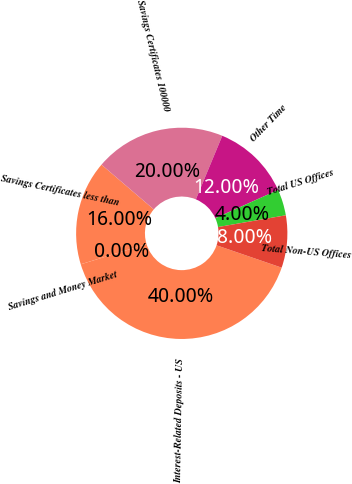<chart> <loc_0><loc_0><loc_500><loc_500><pie_chart><fcel>Interest-Related Deposits - US<fcel>Savings and Money Market<fcel>Savings Certificates less than<fcel>Savings Certificates 100000<fcel>Other Time<fcel>Total US Offices<fcel>Total Non-US Offices<nl><fcel>40.0%<fcel>0.0%<fcel>16.0%<fcel>20.0%<fcel>12.0%<fcel>4.0%<fcel>8.0%<nl></chart> 